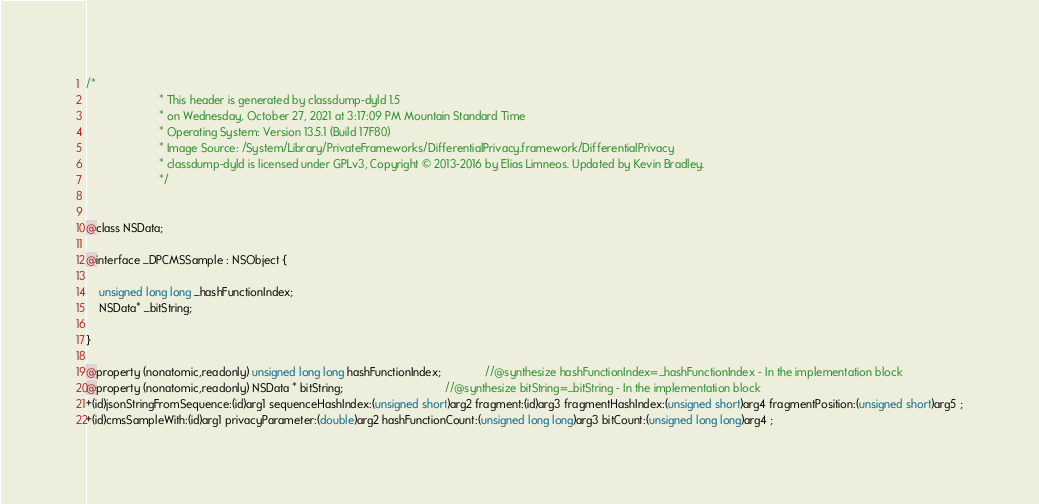<code> <loc_0><loc_0><loc_500><loc_500><_C_>/*
                       * This header is generated by classdump-dyld 1.5
                       * on Wednesday, October 27, 2021 at 3:17:09 PM Mountain Standard Time
                       * Operating System: Version 13.5.1 (Build 17F80)
                       * Image Source: /System/Library/PrivateFrameworks/DifferentialPrivacy.framework/DifferentialPrivacy
                       * classdump-dyld is licensed under GPLv3, Copyright © 2013-2016 by Elias Limneos. Updated by Kevin Bradley.
                       */


@class NSData;

@interface _DPCMSSample : NSObject {

	unsigned long long _hashFunctionIndex;
	NSData* _bitString;

}

@property (nonatomic,readonly) unsigned long long hashFunctionIndex;              //@synthesize hashFunctionIndex=_hashFunctionIndex - In the implementation block
@property (nonatomic,readonly) NSData * bitString;                                //@synthesize bitString=_bitString - In the implementation block
+(id)jsonStringFromSequence:(id)arg1 sequenceHashIndex:(unsigned short)arg2 fragment:(id)arg3 fragmentHashIndex:(unsigned short)arg4 fragmentPosition:(unsigned short)arg5 ;
+(id)cmsSampleWith:(id)arg1 privacyParameter:(double)arg2 hashFunctionCount:(unsigned long long)arg3 bitCount:(unsigned long long)arg4 ;</code> 